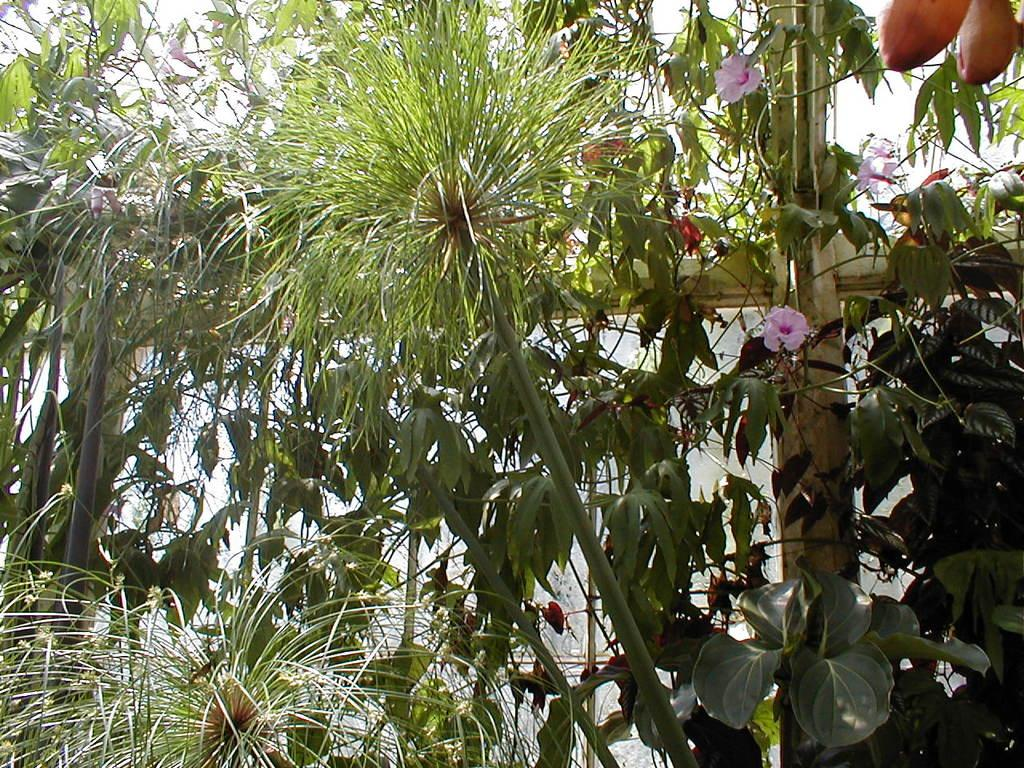What is the main subject of the image? The main subject of the image is the many plants in the middle of the image. Can you describe any specific plants in the image? Yes, there is a plant on the right side of the image with small pink flowers. Are there any fruits visible in the image? Yes, there are two fruits in the top right corner of the image. What type of wound can be seen on the plant in the image? There is no wound visible on any plant in the image. What is being served for dinner in the image? The image does not depict a dinner scene, so it cannot be determined what is being served. 